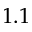Convert formula to latex. <formula><loc_0><loc_0><loc_500><loc_500>1 . 1</formula> 